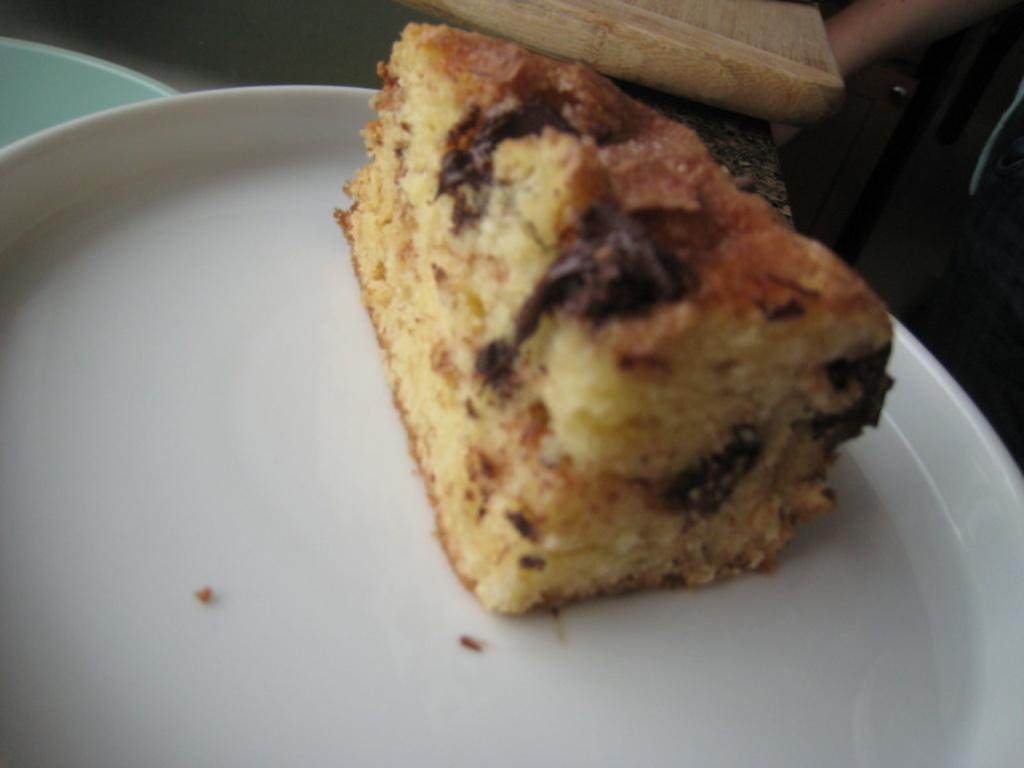What is the main subject of the image? There is a cake on a plate in the image. What color is the plate? The plate is white. What can be seen in the background of the image? There is a wooden object in the background of the image. What type of heart can be seen beating in the image? There is no heart visible in the image; it features a cake on a white plate with a wooden object in the background. What effect does the cake have on the toothbrush in the image? There is no toothbrush present in the image, so it cannot have any effect on it. 